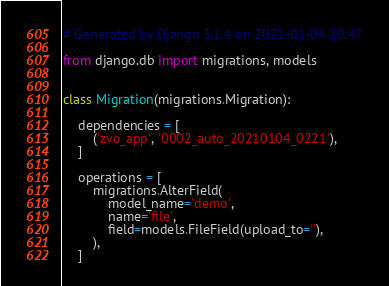<code> <loc_0><loc_0><loc_500><loc_500><_Python_># Generated by Django 3.1.4 on 2021-01-04 20:47

from django.db import migrations, models


class Migration(migrations.Migration):

    dependencies = [
        ('zvo_app', '0002_auto_20210104_0221'),
    ]

    operations = [
        migrations.AlterField(
            model_name='demo',
            name='file',
            field=models.FileField(upload_to=''),
        ),
    ]
</code> 